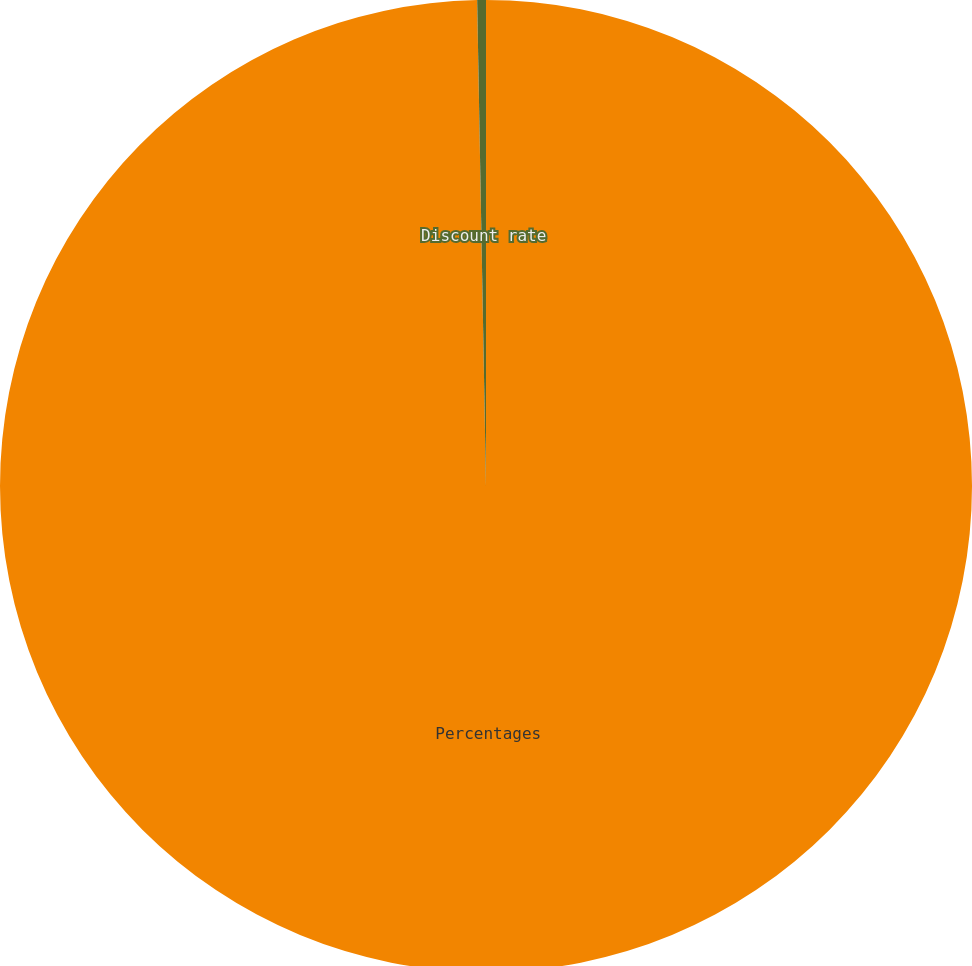Convert chart to OTSL. <chart><loc_0><loc_0><loc_500><loc_500><pie_chart><fcel>Percentages<fcel>Discount rate<nl><fcel>99.71%<fcel>0.29%<nl></chart> 